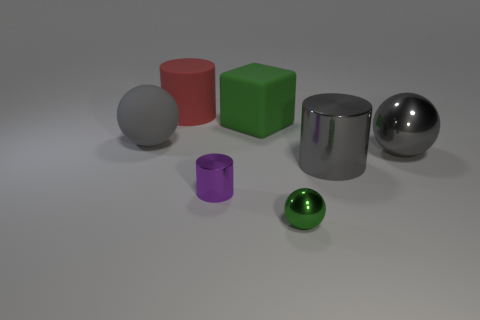Subtract all gray balls. How many were subtracted if there are1gray balls left? 1 Add 1 purple shiny cylinders. How many objects exist? 8 Subtract all cylinders. How many objects are left? 4 Add 6 gray metal objects. How many gray metal objects exist? 8 Subtract 1 green spheres. How many objects are left? 6 Subtract all big purple matte balls. Subtract all big gray balls. How many objects are left? 5 Add 7 big gray matte things. How many big gray matte things are left? 8 